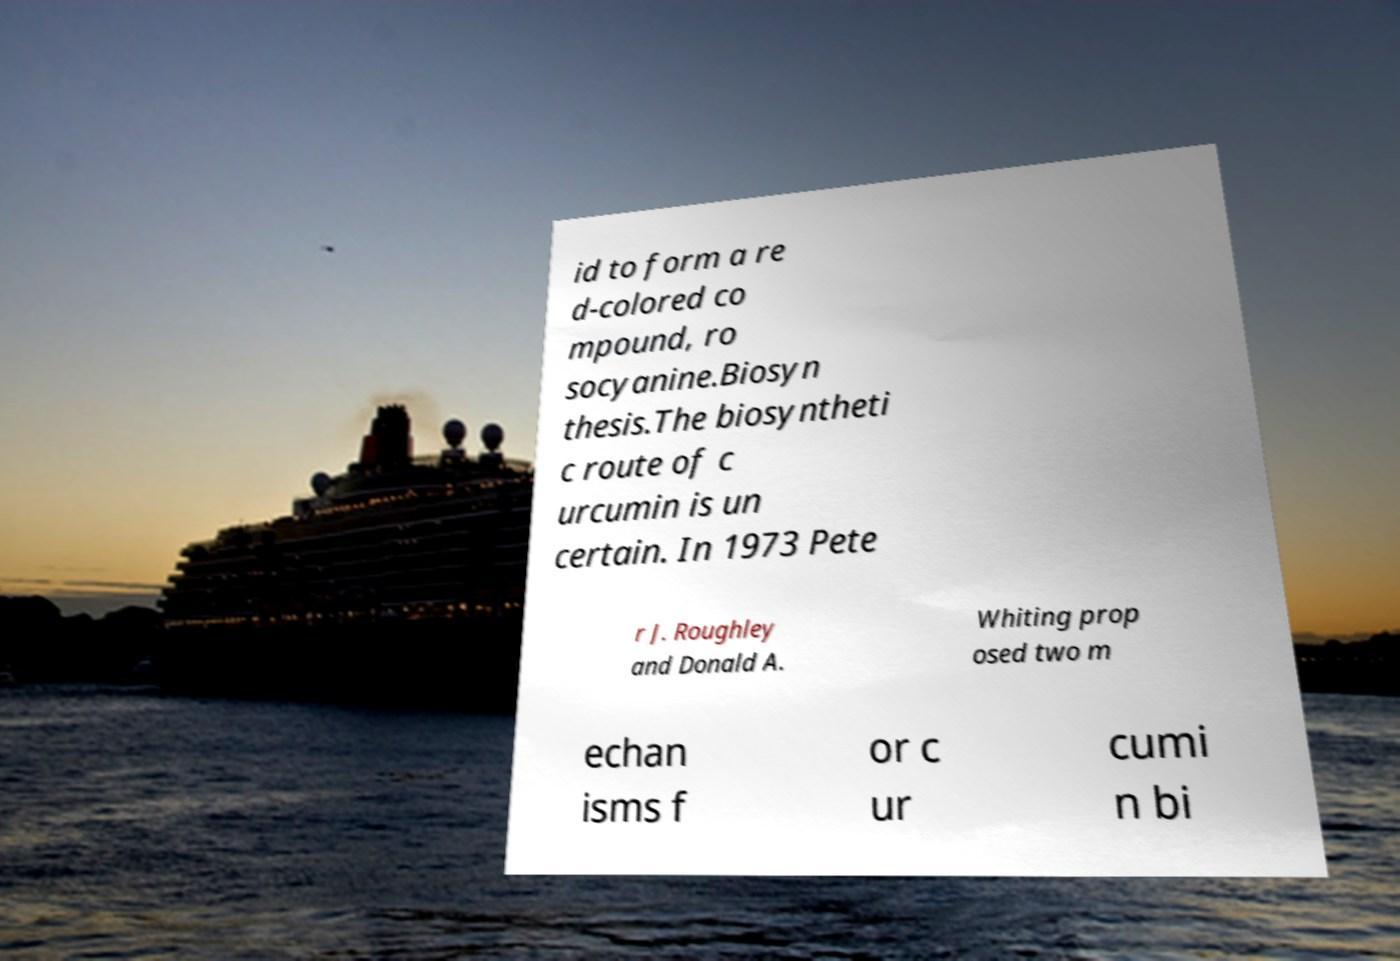Can you accurately transcribe the text from the provided image for me? id to form a re d-colored co mpound, ro socyanine.Biosyn thesis.The biosyntheti c route of c urcumin is un certain. In 1973 Pete r J. Roughley and Donald A. Whiting prop osed two m echan isms f or c ur cumi n bi 